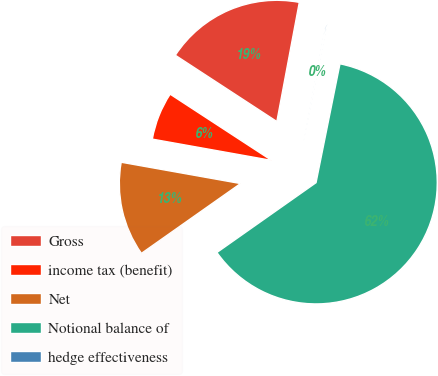Convert chart. <chart><loc_0><loc_0><loc_500><loc_500><pie_chart><fcel>Gross<fcel>income tax (benefit)<fcel>Net<fcel>Notional balance of<fcel>hedge effectiveness<nl><fcel>18.76%<fcel>6.39%<fcel>12.58%<fcel>62.07%<fcel>0.2%<nl></chart> 